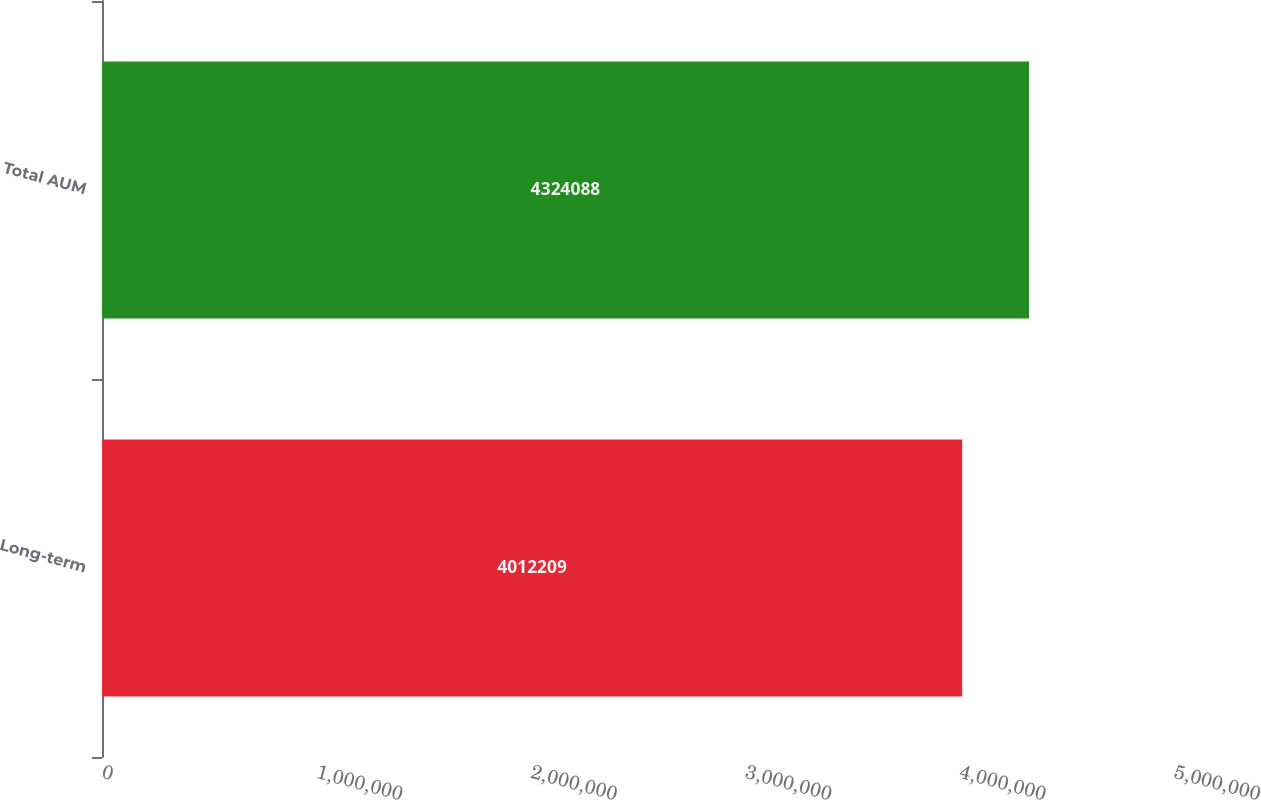Convert chart to OTSL. <chart><loc_0><loc_0><loc_500><loc_500><bar_chart><fcel>Long-term<fcel>Total AUM<nl><fcel>4.01221e+06<fcel>4.32409e+06<nl></chart> 